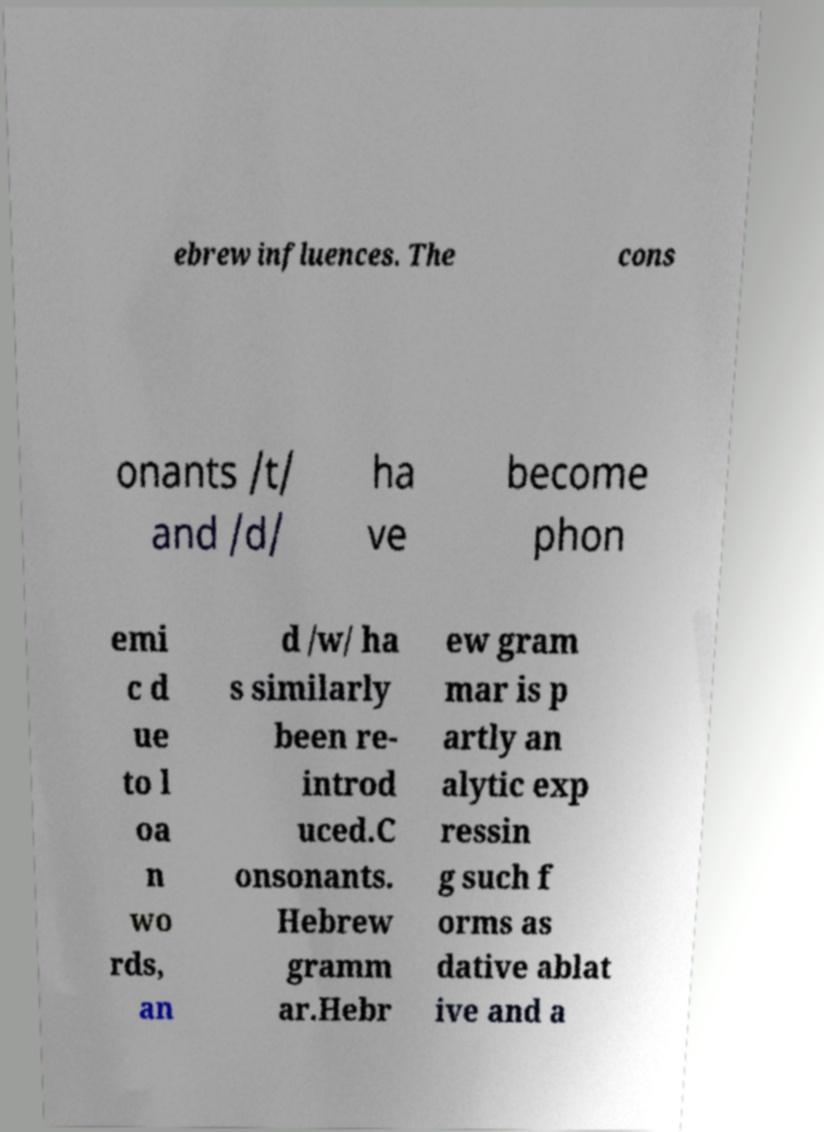I need the written content from this picture converted into text. Can you do that? ebrew influences. The cons onants /t/ and /d/ ha ve become phon emi c d ue to l oa n wo rds, an d /w/ ha s similarly been re- introd uced.C onsonants. Hebrew gramm ar.Hebr ew gram mar is p artly an alytic exp ressin g such f orms as dative ablat ive and a 